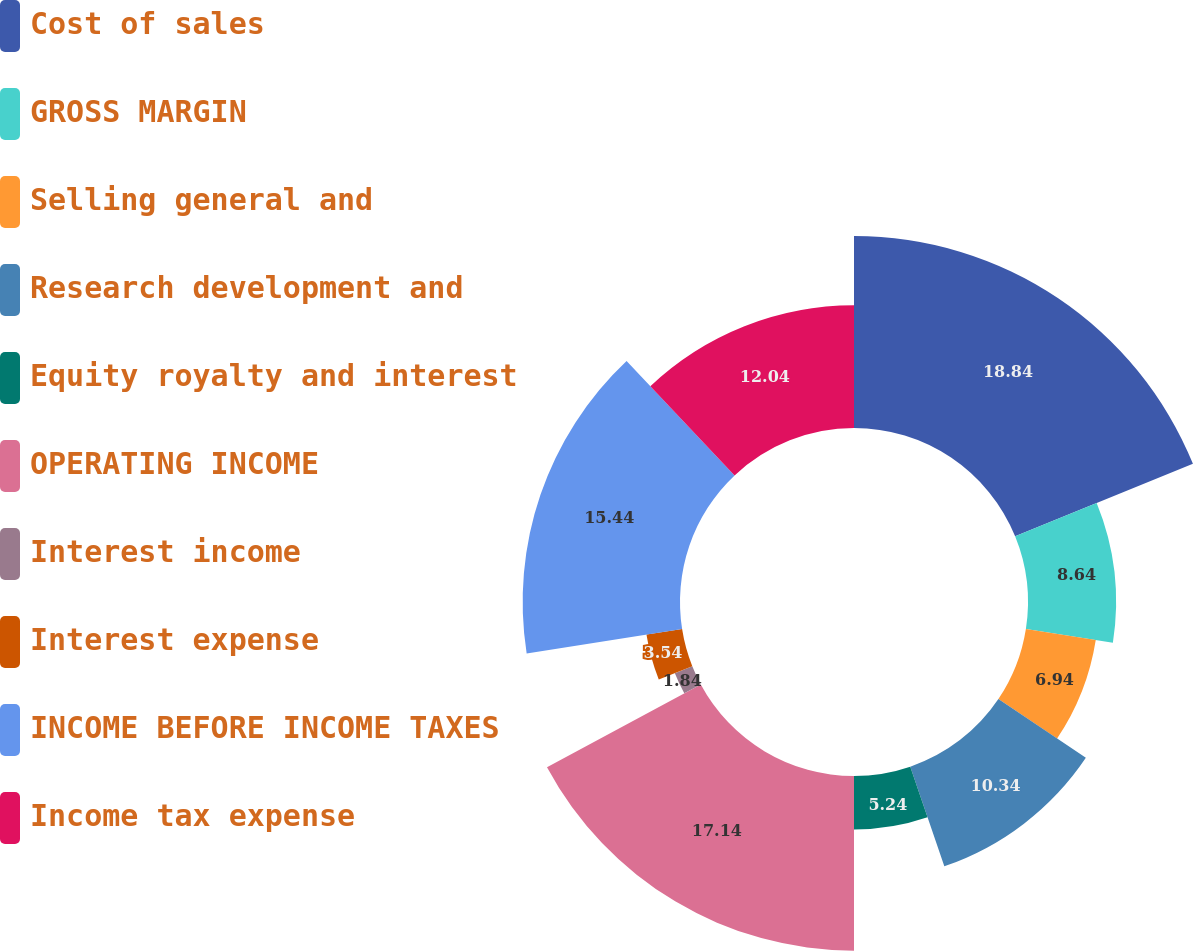Convert chart. <chart><loc_0><loc_0><loc_500><loc_500><pie_chart><fcel>Cost of sales<fcel>GROSS MARGIN<fcel>Selling general and<fcel>Research development and<fcel>Equity royalty and interest<fcel>OPERATING INCOME<fcel>Interest income<fcel>Interest expense<fcel>INCOME BEFORE INCOME TAXES<fcel>Income tax expense<nl><fcel>18.84%<fcel>8.64%<fcel>6.94%<fcel>10.34%<fcel>5.24%<fcel>17.14%<fcel>1.84%<fcel>3.54%<fcel>15.44%<fcel>12.04%<nl></chart> 